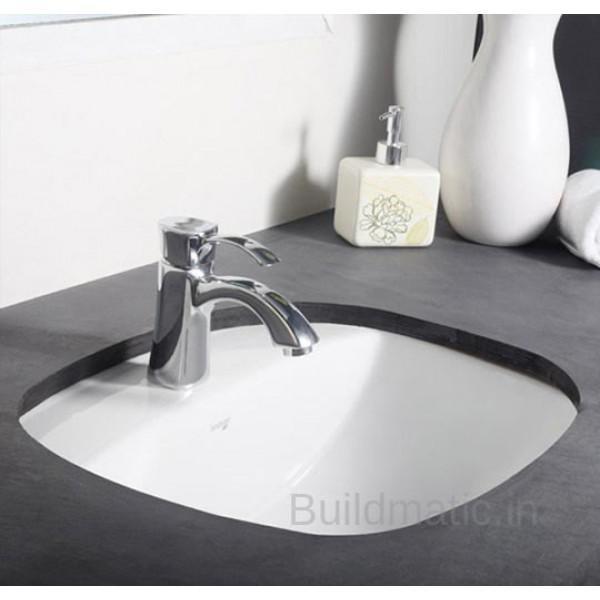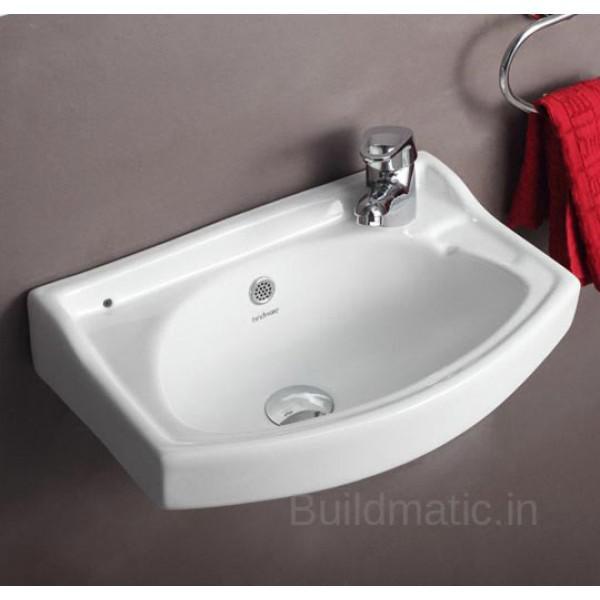The first image is the image on the left, the second image is the image on the right. Examine the images to the left and right. Is the description "In one of the images, there is a white vase with yellow flowers in it" accurate? Answer yes or no. No. 